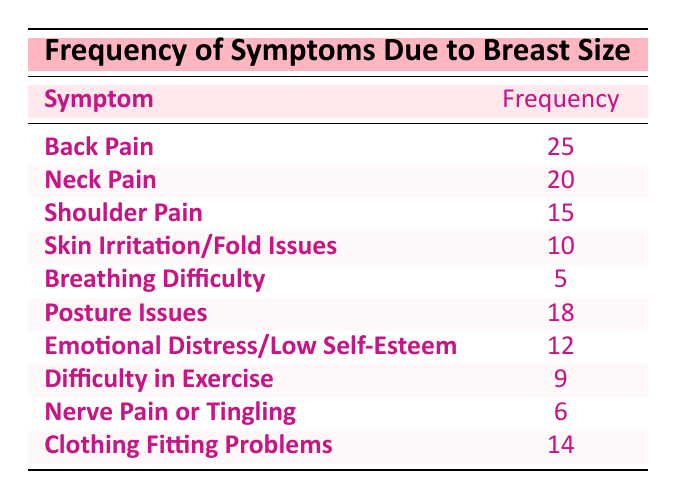What is the most frequent symptom experienced due to breast size? The table lists various symptoms and their frequencies. The symptom with the highest frequency is "Back Pain," which has a frequency of 25.
Answer: Back Pain How many women experienced "Neck Pain"? From the table, the frequency of "Neck Pain" is directly given as 20.
Answer: 20 What is the total frequency of all symptoms listed? To find the total frequency, we add all the frequencies together: 25 + 20 + 15 + 10 + 5 + 18 + 12 + 9 + 6 + 14 =  24 + 20 + 15 + 10 + 5 + 18 + 12 + 9 + 6 + 14 =  25 + 20 = 45, 45 + 15 = 60, 60 + 10 = 70, 70 + 5 = 75, 75 + 18 = 93, 93 + 12 = 105, 105 + 9 = 114, 114 + 6 = 120, 120 + 14 = 134. The total frequency is 134.
Answer: 134 Is "Breathing Difficulty" among the top three symptoms? To answer this, we need to compare the frequency of "Breathing Difficulty," which is 5, with the frequencies of the other symptoms. The top three symptoms have frequencies of 25 (Back Pain), 20 (Neck Pain), and 18 (Posture Issues). Since 5 is less than 18, "Breathing Difficulty" is not in the top three.
Answer: No Which symptoms have a frequency greater than 10? The symptoms and their frequencies that are greater than 10 are "Back Pain" (25), "Neck Pain" (20), "Shoulder Pain" (15), "Posture Issues" (18), and "Emotional Distress/Low Self-Esteem" (12). In total, there are five symptoms with a frequency greater than 10.
Answer: 5 How does the frequency of "Clothing Fitting Problems" compare to "Skin Irritation/Fold Issues"? The table shows that the frequency of "Clothing Fitting Problems" is 14, while "Skin Irritation/Fold Issues" has a frequency of 10. Therefore, "Clothing Fitting Problems" has a higher frequency than "Skin Irritation/Fold Issues."
Answer: Higher What is the frequency difference between "Shoulder Pain" and "Nerve Pain or Tingling"? The frequency of "Shoulder Pain" is 15, and the frequency of "Nerve Pain or Tingling" is 6. The difference is calculated as 15 - 6 = 9. Thus, the frequency difference is 9.
Answer: 9 Are there more women experiencing "Difficulty in Exercise" than "Posture Issues"? From the table, "Difficulty in Exercise" has a frequency of 9, while "Posture Issues" has a frequency of 18. Since 9 is less than 18, there are fewer women experiencing "Difficulty in Exercise."
Answer: No 